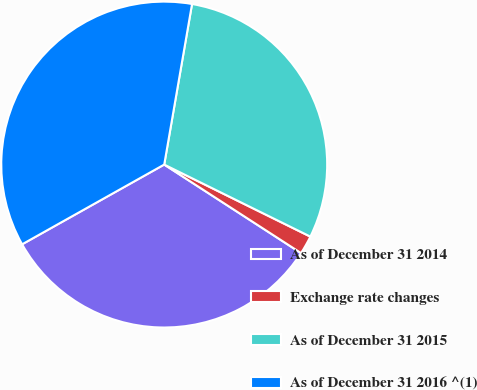<chart> <loc_0><loc_0><loc_500><loc_500><pie_chart><fcel>As of December 31 2014<fcel>Exchange rate changes<fcel>As of December 31 2015<fcel>As of December 31 2016 ^(1)<nl><fcel>32.72%<fcel>1.85%<fcel>29.56%<fcel>35.87%<nl></chart> 